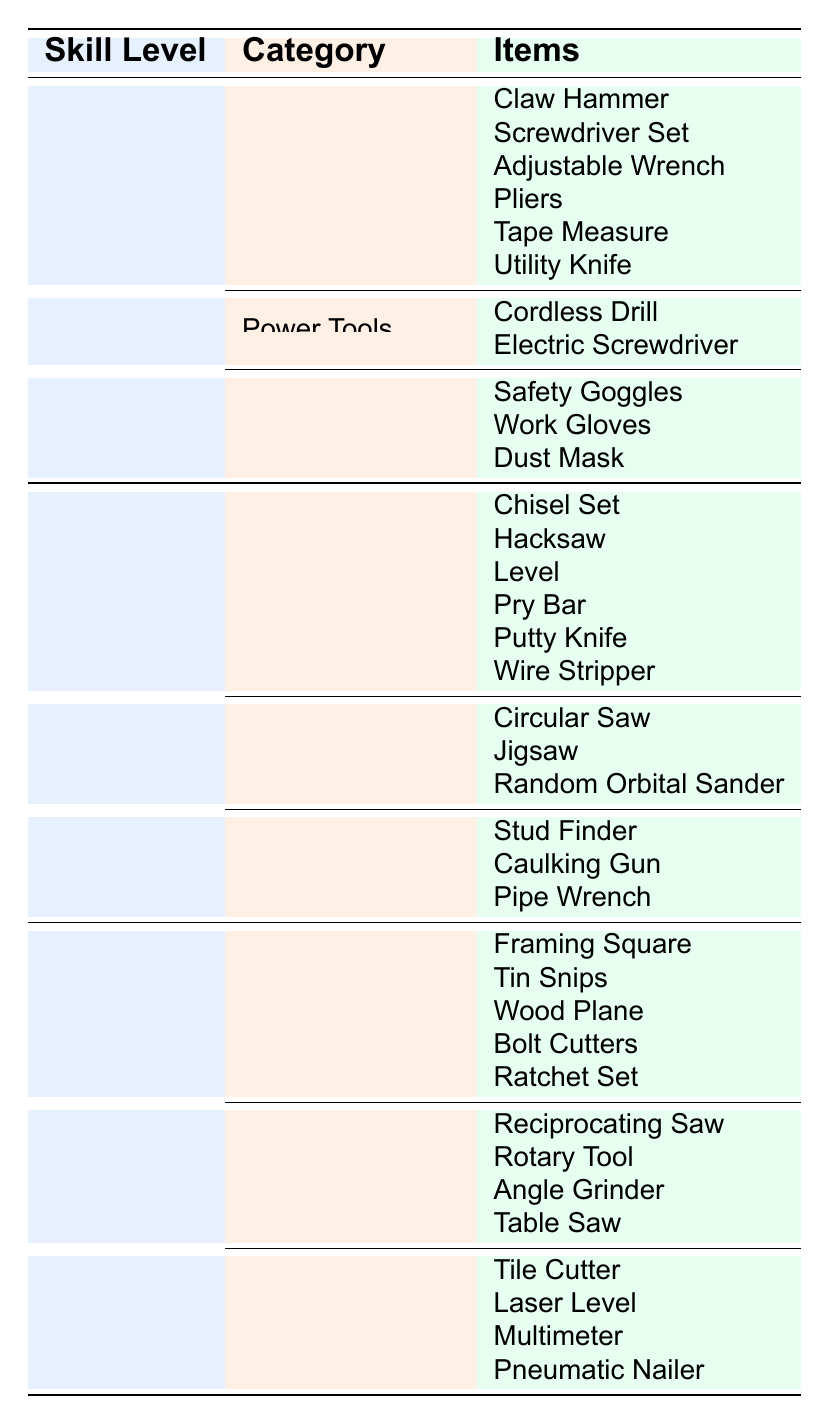What tools are included in the "Safety Equipment" category for beginners? The "Safety Equipment" category for beginners includes three items: Safety Goggles, Work Gloves, and Dust Mask, which can be identified in the table under the Beginner skill level.
Answer: Safety Goggles, Work Gloves, Dust Mask How many hand tools are listed for intermediate skill level? For the intermediate skill level, there are six hand tools listed: Chisel Set, Hacksaw, Level, Pry Bar, Putty Knife, and Wire Stripper, counted directly from the table.
Answer: 6 Is a Circular Saw included in the advanced tools? The Circular Saw is listed under the Power Tools category for the intermediate skill level, not for the advanced skill level, so the answer is no.
Answer: No Which skill level has the highest number of categorized tools? To determine this, we count the number of categories and items listed for each skill level. The beginner level has 3 categories, intermediate has 3, and advanced has 3 as well, but advanced has more total items (12) compared to beginner (9) and intermediate (12). Therefore, advanced has the highest count of categorized tools.
Answer: Advanced How many total items are there for hand tools across all skill levels? For Beginners, there are 6 hand tools, for Intermediate, there are also 6 hand tools, and for Advanced, there are 5 hand tools. Adding these together: 6 + 6 + 5 = 17.
Answer: 17 Which specialized tool is listed for intermediate skill level? The intermediate skill level lists three specialized tools: Stud Finder, Caulking Gun, and Pipe Wrench, identified directly from the table under the intermediate category.
Answer: Stud Finder, Caulking Gun, Pipe Wrench Are there any power tools listed for the beginner skill level? Yes, for the beginner skill level, the table lists two power tools: Cordless Drill and Electric Screwdriver, which directly confirms their presence in the beginner category.
Answer: Yes What is the difference in the number of safety equipment items between beginner and intermediate skill levels? The beginner skill level has 3 safety equipment items, while the intermediate skill level has none. Calculating the difference: 3 - 0 = 3.
Answer: 3 How many unique categories of tools are mentioned overall in the table? There are three unique categories: Hand Tools, Power Tools, and Specialized Tools. Each skill level has these categories represented in some form, confirming the uniqueness.
Answer: 3 Which hand tool is not found in the beginner skill level but is found in the intermediate skill level? The hand tools listed for the intermediate skill level that are not in the beginner skill level include Chisel Set, Hacksaw, Level, Pry Bar, Putty Knife, and Wire Stripper. Thus, any of these can be mentioned as they are absent in the beginner skill level.
Answer: Chisel Set, Hacksaw, Level, Pry Bar, Putty Knife, Wire Stripper 